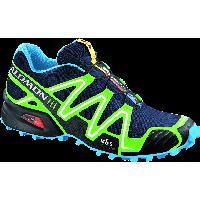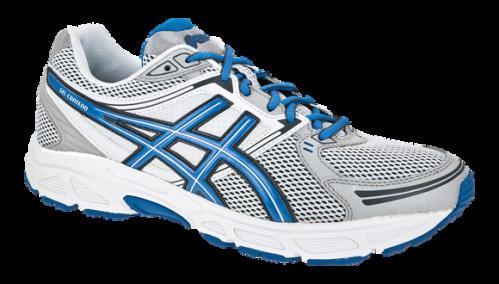The first image is the image on the left, the second image is the image on the right. For the images shown, is this caption "The right image contains exactly one shoe." true? Answer yes or no. Yes. The first image is the image on the left, the second image is the image on the right. Examine the images to the left and right. Is the description "One image shows a pair of sneakers and the other image features a single right-facing sneaker, and all sneakers feature some shade of blue somewhere." accurate? Answer yes or no. No. 